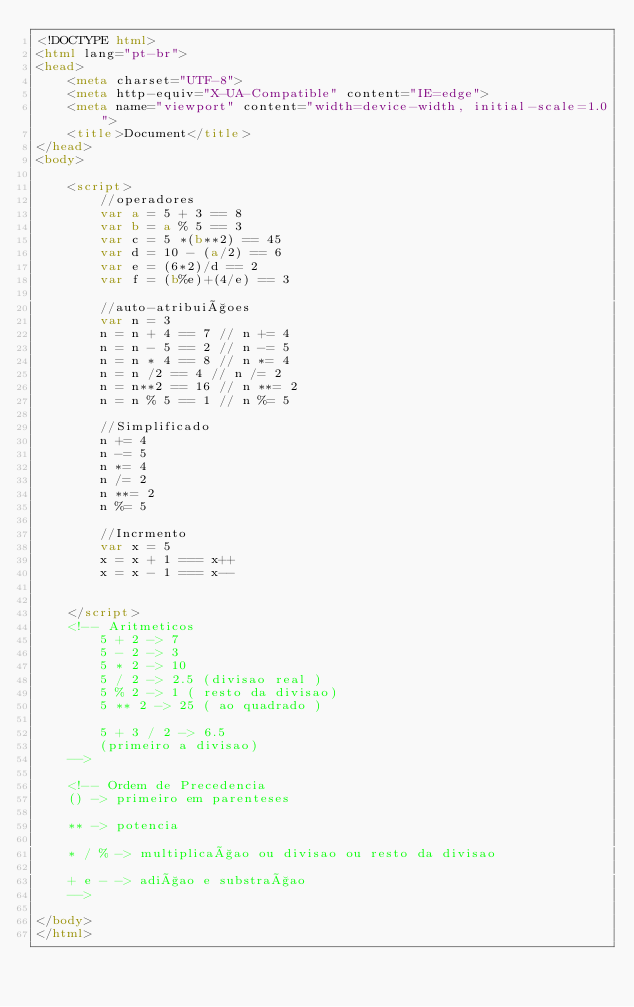<code> <loc_0><loc_0><loc_500><loc_500><_HTML_><!DOCTYPE html>
<html lang="pt-br">
<head>
    <meta charset="UTF-8">
    <meta http-equiv="X-UA-Compatible" content="IE=edge">
    <meta name="viewport" content="width=device-width, initial-scale=1.0">
    <title>Document</title>
</head>
<body>

    <script>
        //operadores
        var a = 5 + 3 == 8
        var b = a % 5 == 3
        var c = 5 *(b**2) == 45
        var d = 10 - (a/2) == 6
        var e = (6*2)/d == 2
        var f = (b%e)+(4/e) == 3

        //auto-atribuiçoes
        var n = 3 
        n = n + 4 == 7 // n += 4
        n = n - 5 == 2 // n -= 5
        n = n * 4 == 8 // n *= 4
        n = n /2 == 4 // n /= 2
        n = n**2 == 16 // n **= 2
        n = n % 5 == 1 // n %= 5

        //Simplificado 
        n += 4
        n -= 5
        n *= 4
        n /= 2
        n **= 2
        n %= 5

        //Incrmento
        var x = 5
        x = x + 1 === x++
        x = x - 1 === x--
        
        
    </script>    
    <!-- Aritmeticos
        5 + 2 -> 7
        5 - 2 -> 3
        5 * 2 -> 10
        5 / 2 -> 2.5 (divisao real )
        5 % 2 -> 1 ( resto da divisao)
        5 ** 2 -> 25 ( ao quadrado )

        5 + 3 / 2 -> 6.5
        (primeiro a divisao)
    -->

    <!-- Ordem de Precedencia
    () -> primeiro em parenteses
    
    ** -> potencia

    * / % -> multiplicaçao ou divisao ou resto da divisao

    + e - -> adiçao e substraçao
    -->

</body>
</html></code> 